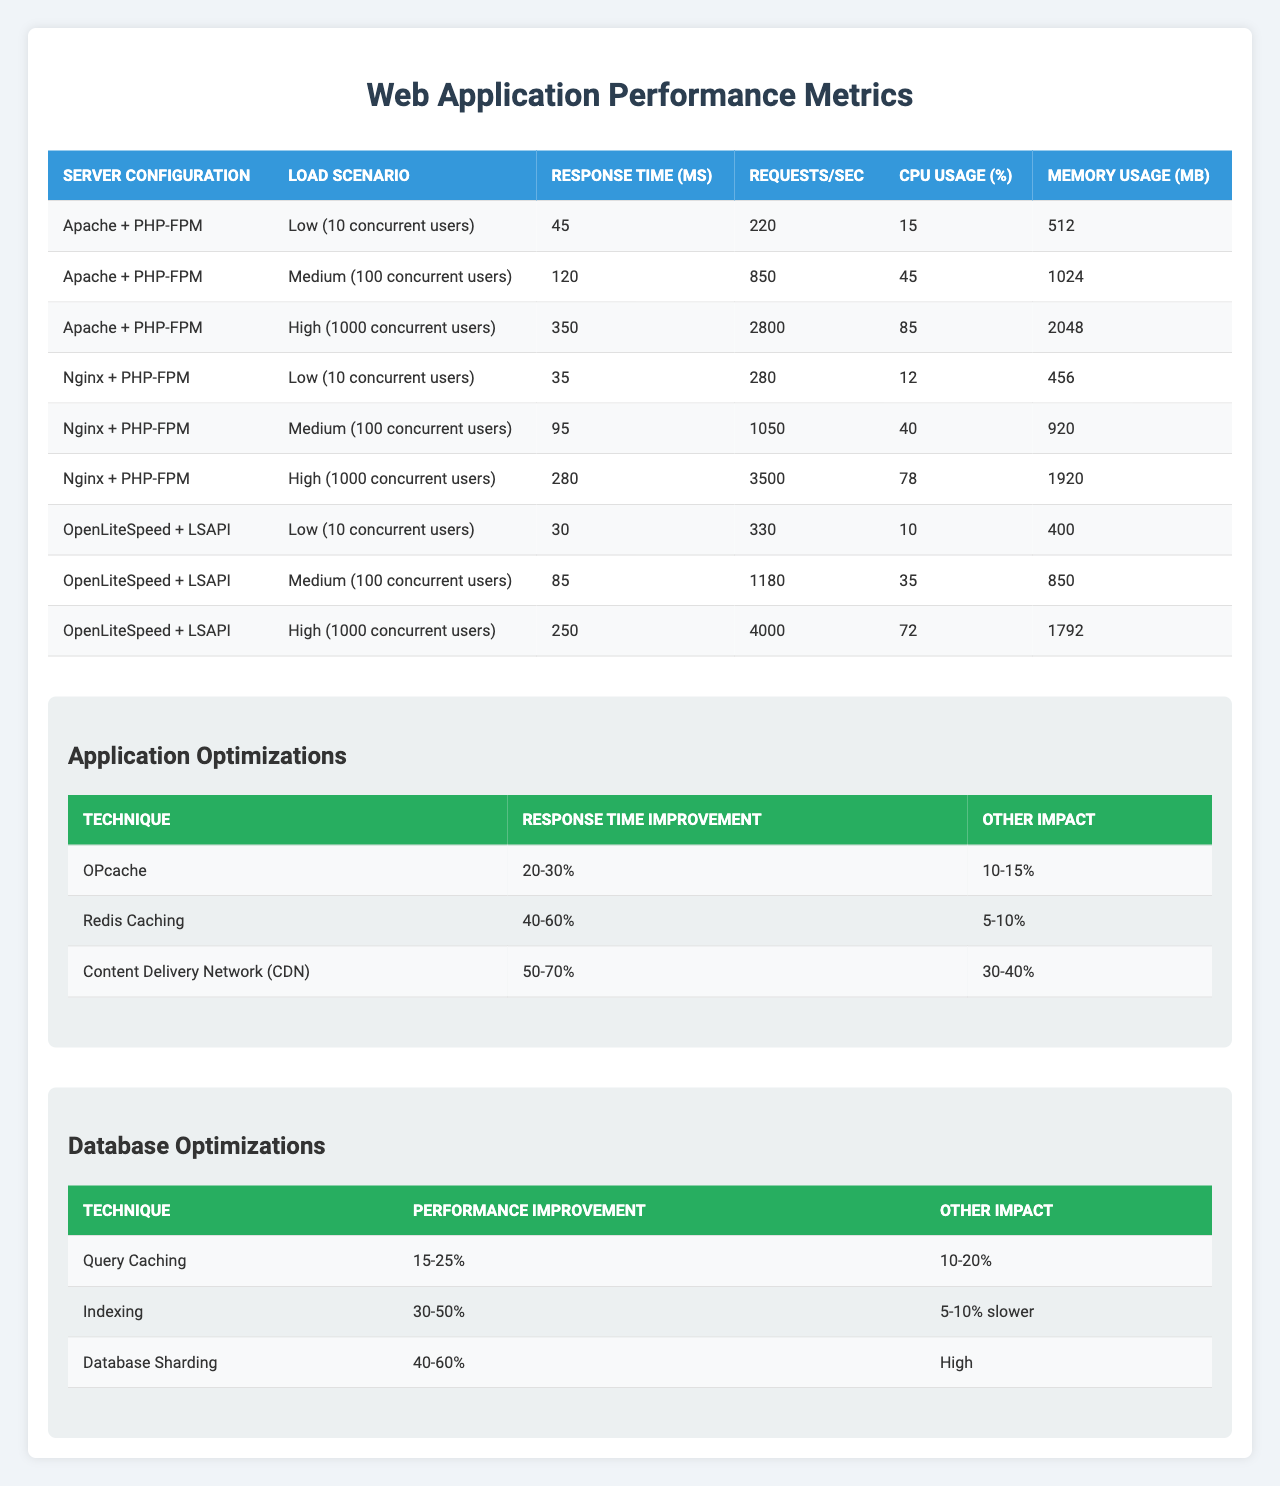What is the response time for Apache + PHP-FPM under high load? According to the table, for the Apache + PHP-FPM configuration under high load (1000 concurrent users), the response time is 350 ms.
Answer: 350 ms Which server configuration has the highest CPU usage under medium load? In the table, for medium load (100 concurrent users), the Apache + PHP-FPM configuration shows a CPU usage of 45%, while Nginx + PHP-FPM shows 40%, and OpenLiteSpeed + LSAPI shows 35%. Therefore, Apache + PHP-FPM has the highest CPU usage.
Answer: Apache + PHP-FPM What is the memory usage for Nginx + PHP-FPM under low load? The table indicates that Nginx + PHP-FPM uses 456 MB of memory under low load (10 concurrent users).
Answer: 456 MB Under which load scenario does OpenLiteSpeed + LSAPI have 4000 requests per second? The table shows that OpenLiteSpeed + LSAPI achieves 4000 requests/sec under high load (1000 concurrent users).
Answer: High load What is the average response time across all server configurations under low load? The response times under low load are: Apache + PHP-FPM (45 ms), Nginx + PHP-FPM (35 ms), and OpenLiteSpeed + LSAPI (30 ms). Their sum is 45 + 35 + 30 = 110 ms, and averaging this gives 110/3 = 36.67 ms.
Answer: 36.67 ms Which optimization technique has the greatest response time improvement? Comparing the response time improvements from application optimizations, Redis Caching offers a 40-60% improvement, which is greater than OPcache (20-30%) and Content Delivery Network (50-70%). Hence, Content Delivery Network has the greatest improvement range.
Answer: Content Delivery Network Does database sharding improve read/write performance? Yes, according to the table, database sharding leads to a read/write performance improvement of 40-60%.
Answer: Yes What is the maximum memory usage reported across all medium load scenarios? The maximum memory usage for medium load (100 concurrent users) is reported for Apache + PHP-FPM at 1024 MB, which is higher than Nginx + PHP-FPM (920 MB) and OpenLiteSpeed + LSAPI (850 MB).
Answer: 1024 MB How much is the CPU usage reduced by query caching? The table shows that query caching results in a CPU usage reduction between 10-20%.
Answer: 10-20% Which optimization technique shows a reduction in server load? The table indicates that the Content Delivery Network (CDN) reduces server load by 30-40%.
Answer: CDN 